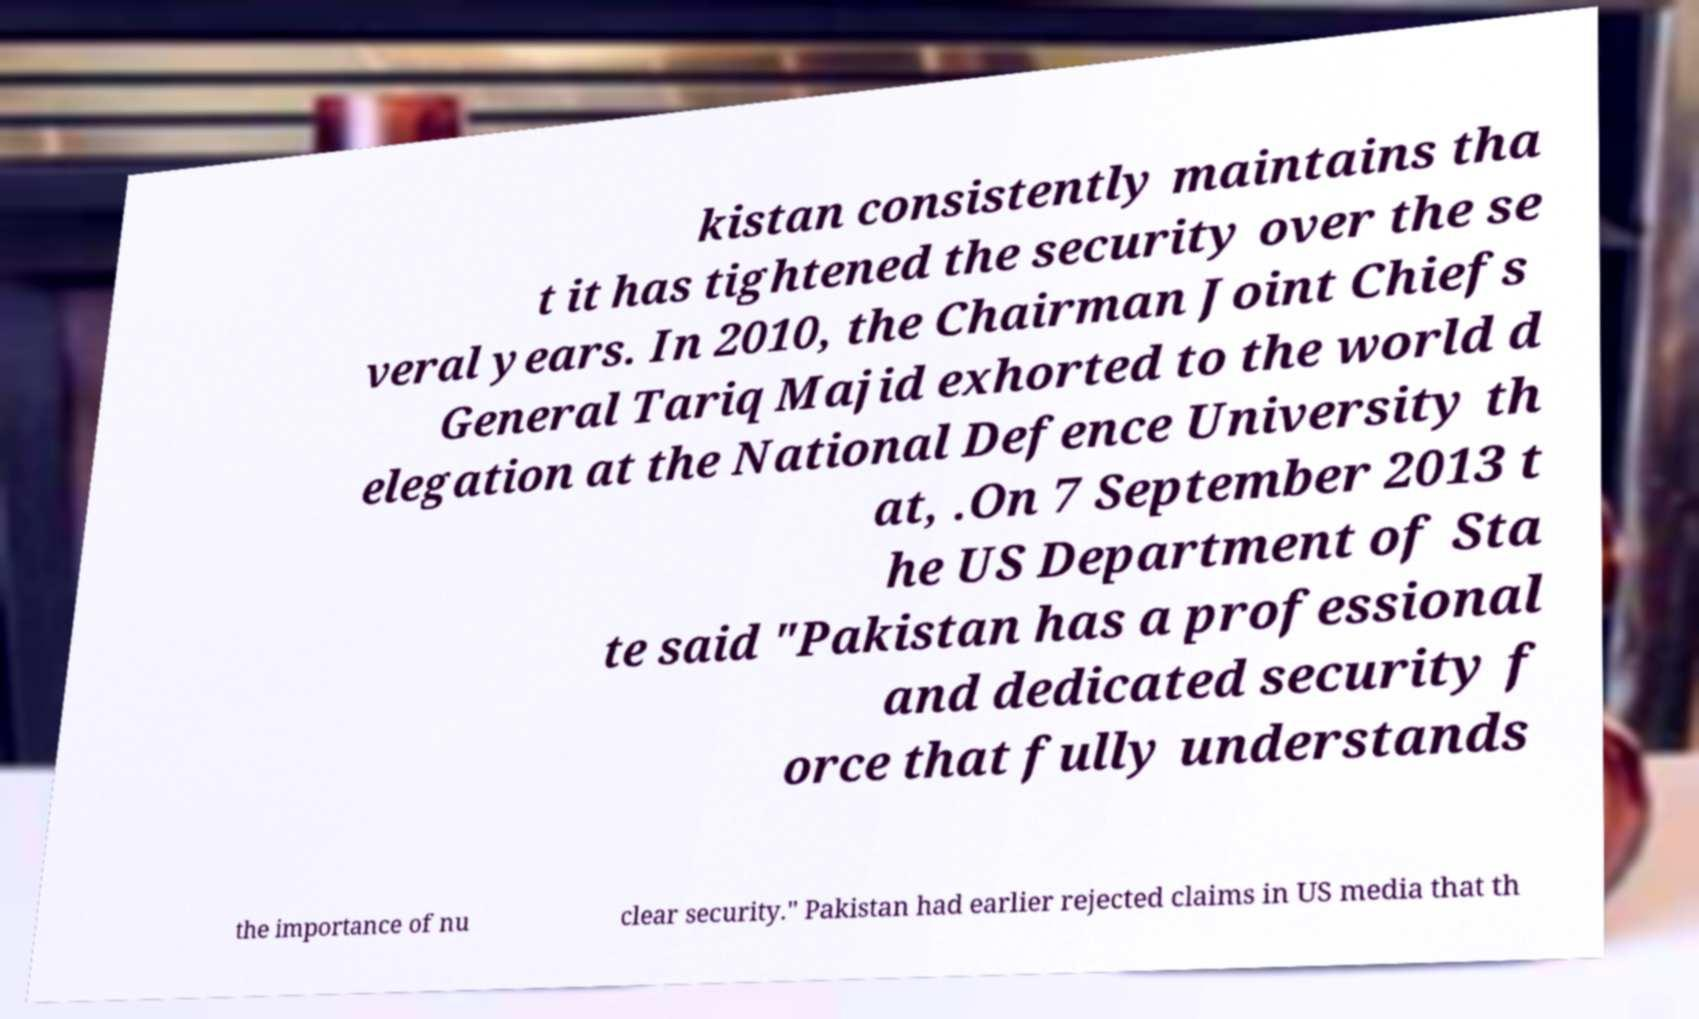Please identify and transcribe the text found in this image. kistan consistently maintains tha t it has tightened the security over the se veral years. In 2010, the Chairman Joint Chiefs General Tariq Majid exhorted to the world d elegation at the National Defence University th at, .On 7 September 2013 t he US Department of Sta te said "Pakistan has a professional and dedicated security f orce that fully understands the importance of nu clear security." Pakistan had earlier rejected claims in US media that th 